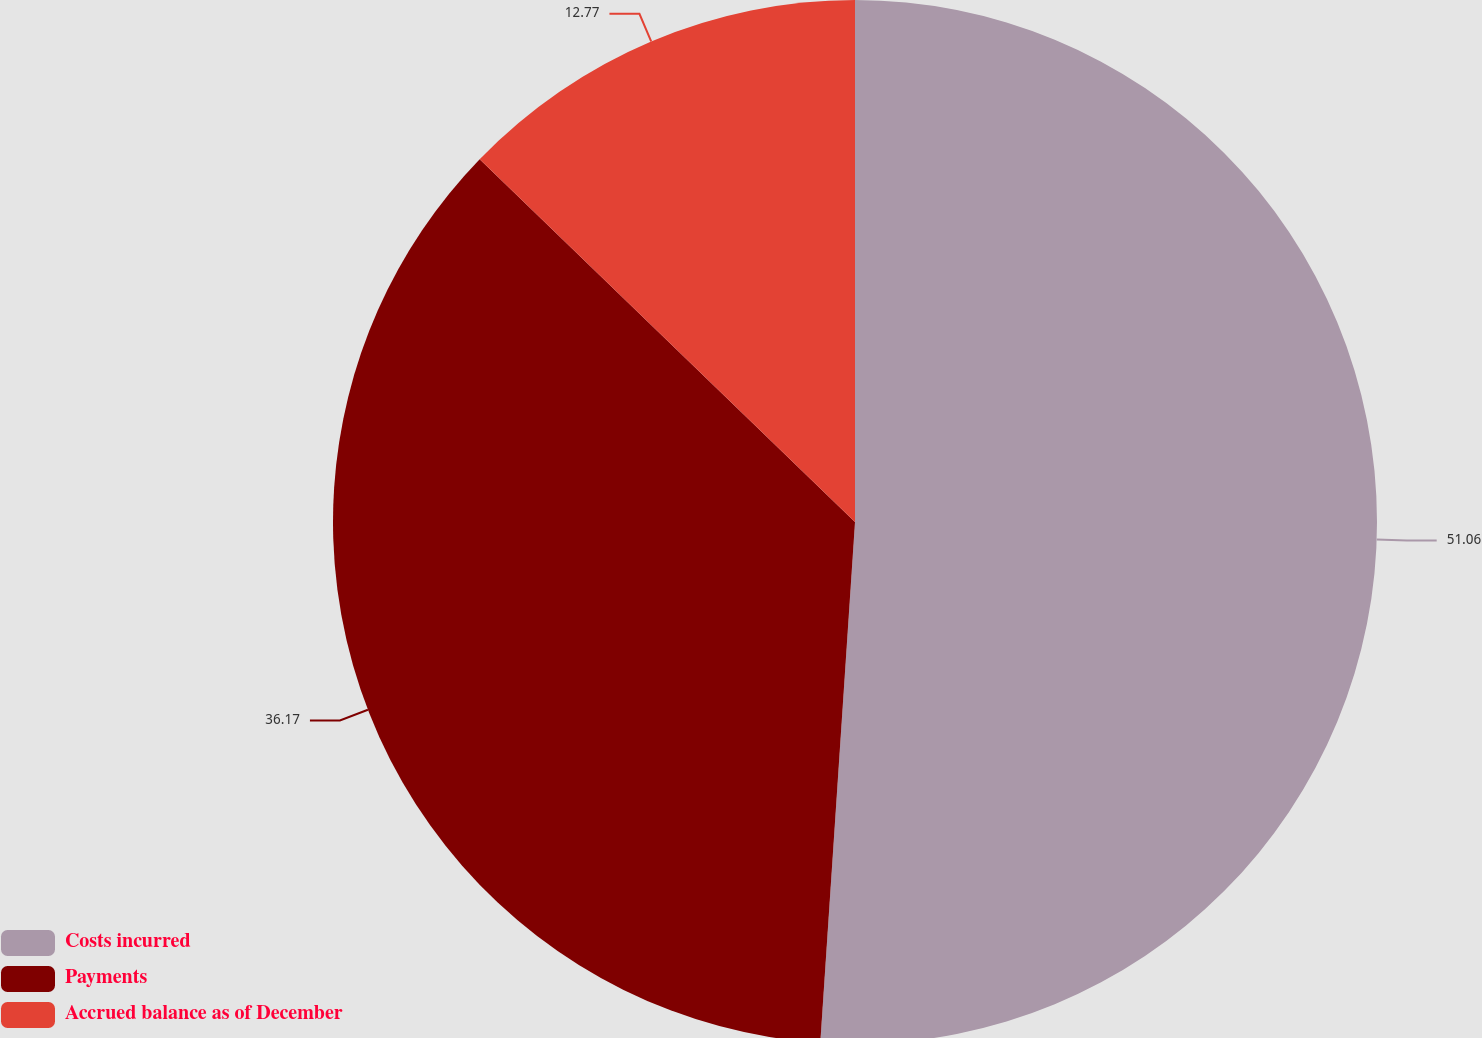<chart> <loc_0><loc_0><loc_500><loc_500><pie_chart><fcel>Costs incurred<fcel>Payments<fcel>Accrued balance as of December<nl><fcel>51.06%<fcel>36.17%<fcel>12.77%<nl></chart> 